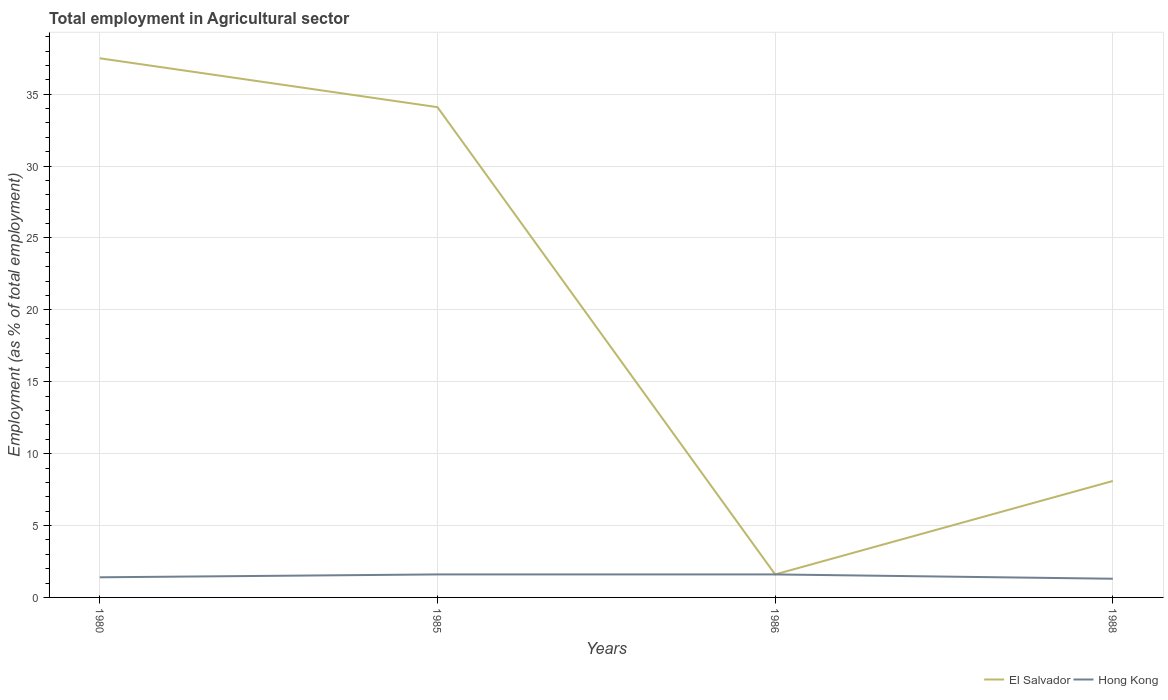How many different coloured lines are there?
Ensure brevity in your answer.  2. Is the number of lines equal to the number of legend labels?
Your answer should be compact. Yes. Across all years, what is the maximum employment in agricultural sector in El Salvador?
Ensure brevity in your answer.  1.6. What is the total employment in agricultural sector in Hong Kong in the graph?
Your answer should be very brief. -0.2. What is the difference between the highest and the second highest employment in agricultural sector in Hong Kong?
Your answer should be very brief. 0.3. What is the difference between the highest and the lowest employment in agricultural sector in El Salvador?
Provide a succinct answer. 2. Are the values on the major ticks of Y-axis written in scientific E-notation?
Your answer should be very brief. No. Does the graph contain grids?
Offer a terse response. Yes. How many legend labels are there?
Make the answer very short. 2. How are the legend labels stacked?
Your response must be concise. Horizontal. What is the title of the graph?
Keep it short and to the point. Total employment in Agricultural sector. What is the label or title of the X-axis?
Ensure brevity in your answer.  Years. What is the label or title of the Y-axis?
Provide a succinct answer. Employment (as % of total employment). What is the Employment (as % of total employment) in El Salvador in 1980?
Offer a very short reply. 37.5. What is the Employment (as % of total employment) in Hong Kong in 1980?
Give a very brief answer. 1.4. What is the Employment (as % of total employment) in El Salvador in 1985?
Offer a terse response. 34.1. What is the Employment (as % of total employment) in Hong Kong in 1985?
Your answer should be compact. 1.6. What is the Employment (as % of total employment) of El Salvador in 1986?
Give a very brief answer. 1.6. What is the Employment (as % of total employment) of Hong Kong in 1986?
Make the answer very short. 1.6. What is the Employment (as % of total employment) in El Salvador in 1988?
Ensure brevity in your answer.  8.1. What is the Employment (as % of total employment) in Hong Kong in 1988?
Give a very brief answer. 1.3. Across all years, what is the maximum Employment (as % of total employment) in El Salvador?
Offer a terse response. 37.5. Across all years, what is the maximum Employment (as % of total employment) of Hong Kong?
Make the answer very short. 1.6. Across all years, what is the minimum Employment (as % of total employment) in El Salvador?
Your response must be concise. 1.6. Across all years, what is the minimum Employment (as % of total employment) in Hong Kong?
Make the answer very short. 1.3. What is the total Employment (as % of total employment) of El Salvador in the graph?
Keep it short and to the point. 81.3. What is the total Employment (as % of total employment) in Hong Kong in the graph?
Offer a very short reply. 5.9. What is the difference between the Employment (as % of total employment) of El Salvador in 1980 and that in 1986?
Keep it short and to the point. 35.9. What is the difference between the Employment (as % of total employment) of El Salvador in 1980 and that in 1988?
Ensure brevity in your answer.  29.4. What is the difference between the Employment (as % of total employment) in Hong Kong in 1980 and that in 1988?
Offer a very short reply. 0.1. What is the difference between the Employment (as % of total employment) in El Salvador in 1985 and that in 1986?
Offer a terse response. 32.5. What is the difference between the Employment (as % of total employment) of Hong Kong in 1985 and that in 1988?
Provide a short and direct response. 0.3. What is the difference between the Employment (as % of total employment) of El Salvador in 1980 and the Employment (as % of total employment) of Hong Kong in 1985?
Your response must be concise. 35.9. What is the difference between the Employment (as % of total employment) in El Salvador in 1980 and the Employment (as % of total employment) in Hong Kong in 1986?
Give a very brief answer. 35.9. What is the difference between the Employment (as % of total employment) of El Salvador in 1980 and the Employment (as % of total employment) of Hong Kong in 1988?
Ensure brevity in your answer.  36.2. What is the difference between the Employment (as % of total employment) of El Salvador in 1985 and the Employment (as % of total employment) of Hong Kong in 1986?
Keep it short and to the point. 32.5. What is the difference between the Employment (as % of total employment) in El Salvador in 1985 and the Employment (as % of total employment) in Hong Kong in 1988?
Ensure brevity in your answer.  32.8. What is the average Employment (as % of total employment) in El Salvador per year?
Provide a short and direct response. 20.32. What is the average Employment (as % of total employment) in Hong Kong per year?
Offer a very short reply. 1.48. In the year 1980, what is the difference between the Employment (as % of total employment) of El Salvador and Employment (as % of total employment) of Hong Kong?
Make the answer very short. 36.1. In the year 1985, what is the difference between the Employment (as % of total employment) in El Salvador and Employment (as % of total employment) in Hong Kong?
Keep it short and to the point. 32.5. In the year 1986, what is the difference between the Employment (as % of total employment) in El Salvador and Employment (as % of total employment) in Hong Kong?
Provide a short and direct response. 0. What is the ratio of the Employment (as % of total employment) of El Salvador in 1980 to that in 1985?
Ensure brevity in your answer.  1.1. What is the ratio of the Employment (as % of total employment) of Hong Kong in 1980 to that in 1985?
Your answer should be compact. 0.88. What is the ratio of the Employment (as % of total employment) of El Salvador in 1980 to that in 1986?
Your answer should be compact. 23.44. What is the ratio of the Employment (as % of total employment) of Hong Kong in 1980 to that in 1986?
Offer a very short reply. 0.88. What is the ratio of the Employment (as % of total employment) of El Salvador in 1980 to that in 1988?
Offer a very short reply. 4.63. What is the ratio of the Employment (as % of total employment) of Hong Kong in 1980 to that in 1988?
Keep it short and to the point. 1.08. What is the ratio of the Employment (as % of total employment) of El Salvador in 1985 to that in 1986?
Provide a succinct answer. 21.31. What is the ratio of the Employment (as % of total employment) of El Salvador in 1985 to that in 1988?
Your response must be concise. 4.21. What is the ratio of the Employment (as % of total employment) of Hong Kong in 1985 to that in 1988?
Your answer should be very brief. 1.23. What is the ratio of the Employment (as % of total employment) of El Salvador in 1986 to that in 1988?
Your answer should be very brief. 0.2. What is the ratio of the Employment (as % of total employment) in Hong Kong in 1986 to that in 1988?
Provide a short and direct response. 1.23. What is the difference between the highest and the second highest Employment (as % of total employment) in El Salvador?
Make the answer very short. 3.4. What is the difference between the highest and the lowest Employment (as % of total employment) in El Salvador?
Make the answer very short. 35.9. What is the difference between the highest and the lowest Employment (as % of total employment) in Hong Kong?
Your response must be concise. 0.3. 